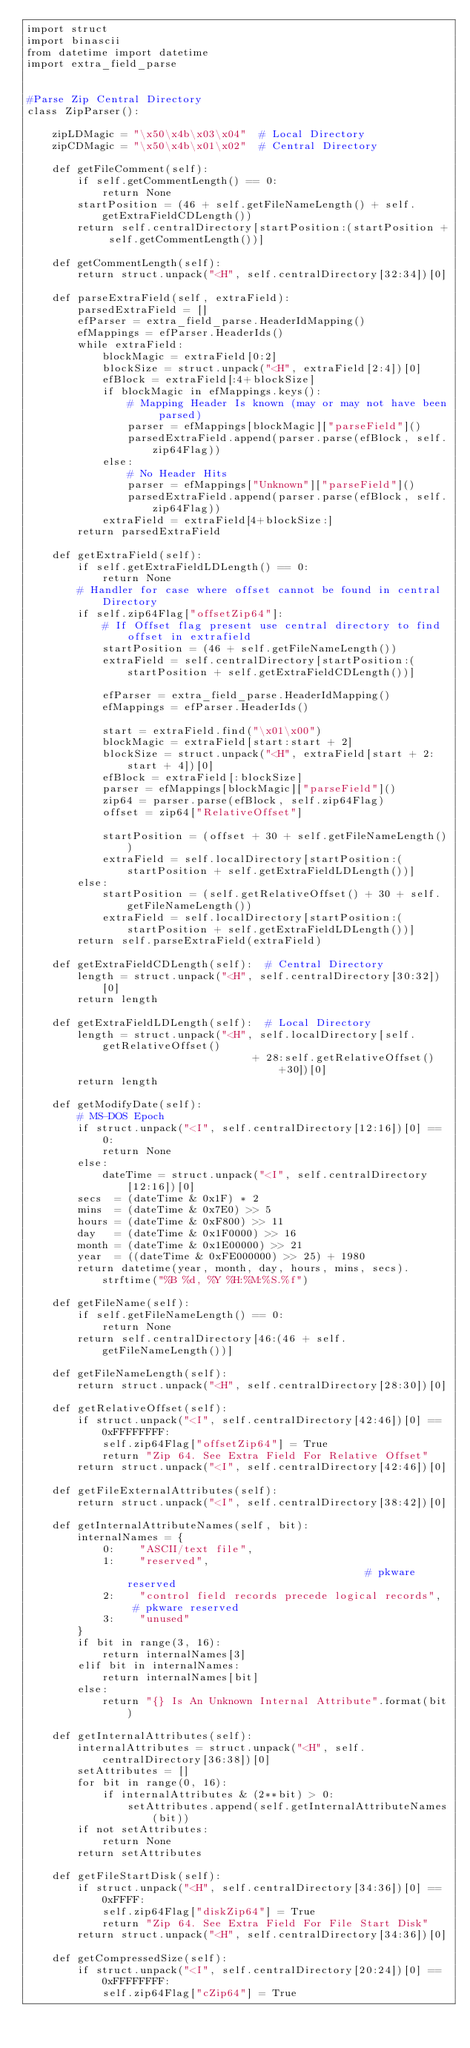<code> <loc_0><loc_0><loc_500><loc_500><_Python_>import struct
import binascii
from datetime import datetime
import extra_field_parse


#Parse Zip Central Directory
class ZipParser():

    zipLDMagic = "\x50\x4b\x03\x04"  # Local Directory
    zipCDMagic = "\x50\x4b\x01\x02"  # Central Directory

    def getFileComment(self):
        if self.getCommentLength() == 0:
            return None
        startPosition = (46 + self.getFileNameLength() + self.getExtraFieldCDLength())
        return self.centralDirectory[startPosition:(startPosition + self.getCommentLength())]

    def getCommentLength(self):
        return struct.unpack("<H", self.centralDirectory[32:34])[0]

    def parseExtraField(self, extraField):
        parsedExtraField = []
        efParser = extra_field_parse.HeaderIdMapping()
        efMappings = efParser.HeaderIds()
        while extraField:
            blockMagic = extraField[0:2]
            blockSize = struct.unpack("<H", extraField[2:4])[0]
            efBlock = extraField[:4+blockSize]
            if blockMagic in efMappings.keys():
                # Mapping Header Is known (may or may not have been parsed)
                parser = efMappings[blockMagic]["parseField"]()
                parsedExtraField.append(parser.parse(efBlock, self.zip64Flag))
            else:
                # No Header Hits
                parser = efMappings["Unknown"]["parseField"]()
                parsedExtraField.append(parser.parse(efBlock, self.zip64Flag))
            extraField = extraField[4+blockSize:]
        return parsedExtraField

    def getExtraField(self):
        if self.getExtraFieldLDLength() == 0:
            return None
        # Handler for case where offset cannot be found in central Directory
        if self.zip64Flag["offsetZip64"]:
            # If Offset flag present use central directory to find offset in extrafield
            startPosition = (46 + self.getFileNameLength())
            extraField = self.centralDirectory[startPosition:(startPosition + self.getExtraFieldCDLength())]

            efParser = extra_field_parse.HeaderIdMapping()
            efMappings = efParser.HeaderIds()

            start = extraField.find("\x01\x00")
            blockMagic = extraField[start:start + 2]
            blockSize = struct.unpack("<H", extraField[start + 2:start + 4])[0]
            efBlock = extraField[:blockSize]
            parser = efMappings[blockMagic]["parseField"]()
            zip64 = parser.parse(efBlock, self.zip64Flag)
            offset = zip64["RelativeOffset"]

            startPosition = (offset + 30 + self.getFileNameLength())
            extraField = self.localDirectory[startPosition:(startPosition + self.getExtraFieldLDLength())]
        else:
            startPosition = (self.getRelativeOffset() + 30 + self.getFileNameLength())
            extraField = self.localDirectory[startPosition:(startPosition + self.getExtraFieldLDLength())]
        return self.parseExtraField(extraField)

    def getExtraFieldCDLength(self):  # Central Directory
        length = struct.unpack("<H", self.centralDirectory[30:32])[0]
        return length

    def getExtraFieldLDLength(self):  # Local Directory
        length = struct.unpack("<H", self.localDirectory[self.getRelativeOffset()
                                    + 28:self.getRelativeOffset()+30])[0]
        return length

    def getModifyDate(self):
        # MS-DOS Epoch
        if struct.unpack("<I", self.centralDirectory[12:16])[0] == 0:
            return None
        else:
            dateTime = struct.unpack("<I", self.centralDirectory[12:16])[0]
        secs  = (dateTime & 0x1F) * 2
        mins  = (dateTime & 0x7E0) >> 5
        hours = (dateTime & 0xF800) >> 11
        day   = (dateTime & 0x1F0000) >> 16
        month = (dateTime & 0x1E00000) >> 21
        year  = ((dateTime & 0xFE000000) >> 25) + 1980
        return datetime(year, month, day, hours, mins, secs).strftime("%B %d, %Y %H:%M:%S.%f")

    def getFileName(self):
        if self.getFileNameLength() == 0:
            return None
        return self.centralDirectory[46:(46 + self.getFileNameLength())]

    def getFileNameLength(self):
        return struct.unpack("<H", self.centralDirectory[28:30])[0]

    def getRelativeOffset(self):
        if struct.unpack("<I", self.centralDirectory[42:46])[0] == 0xFFFFFFFF:
            self.zip64Flag["offsetZip64"] = True
            return "Zip 64. See Extra Field For Relative Offset"
        return struct.unpack("<I", self.centralDirectory[42:46])[0]

    def getFileExternalAttributes(self):
        return struct.unpack("<I", self.centralDirectory[38:42])[0]

    def getInternalAttributeNames(self, bit):
        internalNames = {
            0:    "ASCII/text file",
            1:    "reserved",                                       # pkware reserved
            2:    "control field records precede logical records",  # pkware reserved
            3:    "unused"
        }
        if bit in range(3, 16):
            return internalNames[3]
        elif bit in internalNames:
            return internalNames[bit]
        else:
            return "{} Is An Unknown Internal Attribute".format(bit)

    def getInternalAttributes(self):
        internalAttributes = struct.unpack("<H", self.centralDirectory[36:38])[0]
        setAttributes = []
        for bit in range(0, 16):
            if internalAttributes & (2**bit) > 0:
                setAttributes.append(self.getInternalAttributeNames(bit))
        if not setAttributes:
            return None
        return setAttributes

    def getFileStartDisk(self):
        if struct.unpack("<H", self.centralDirectory[34:36])[0] == 0xFFFF:
            self.zip64Flag["diskZip64"] = True
            return "Zip 64. See Extra Field For File Start Disk"
        return struct.unpack("<H", self.centralDirectory[34:36])[0]

    def getCompressedSize(self):
        if struct.unpack("<I", self.centralDirectory[20:24])[0] == 0xFFFFFFFF:
            self.zip64Flag["cZip64"] = True</code> 